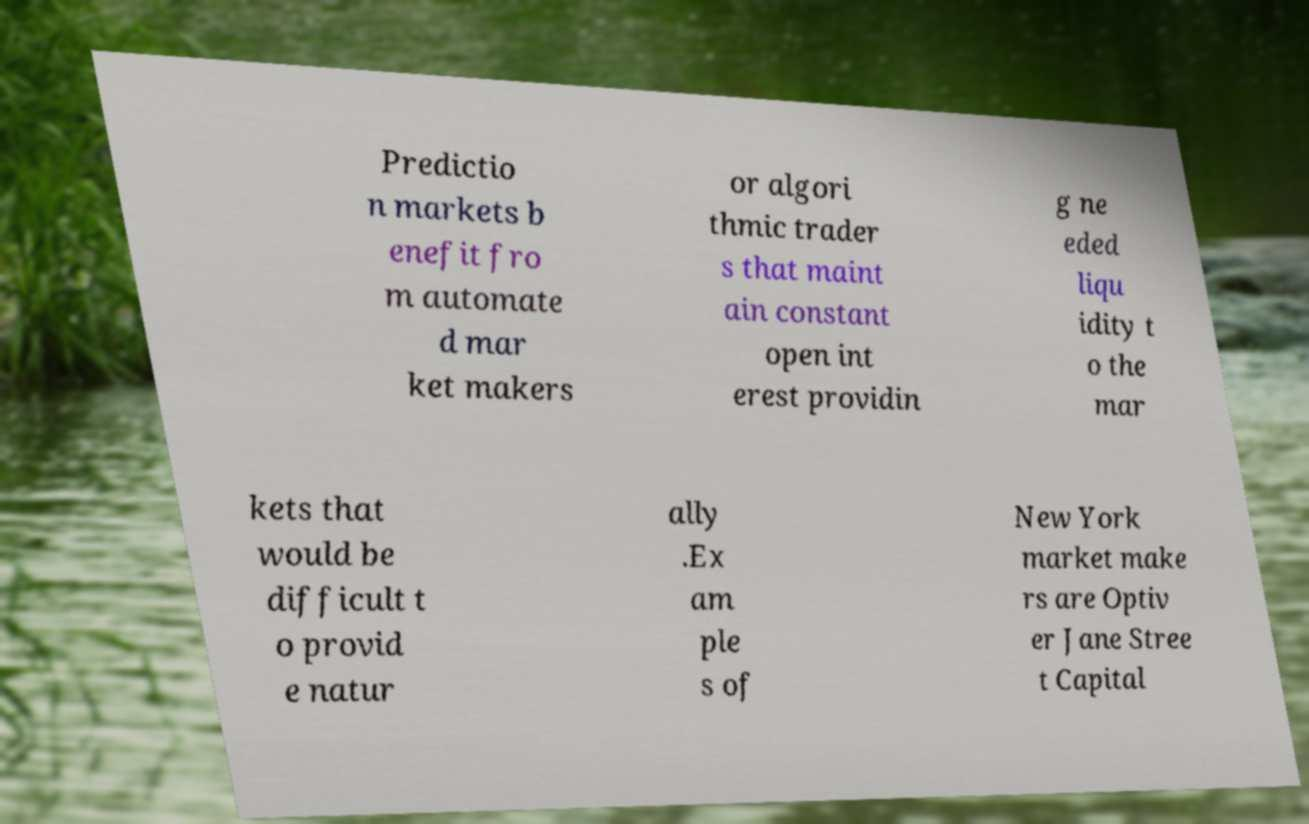Could you extract and type out the text from this image? Predictio n markets b enefit fro m automate d mar ket makers or algori thmic trader s that maint ain constant open int erest providin g ne eded liqu idity t o the mar kets that would be difficult t o provid e natur ally .Ex am ple s of New York market make rs are Optiv er Jane Stree t Capital 